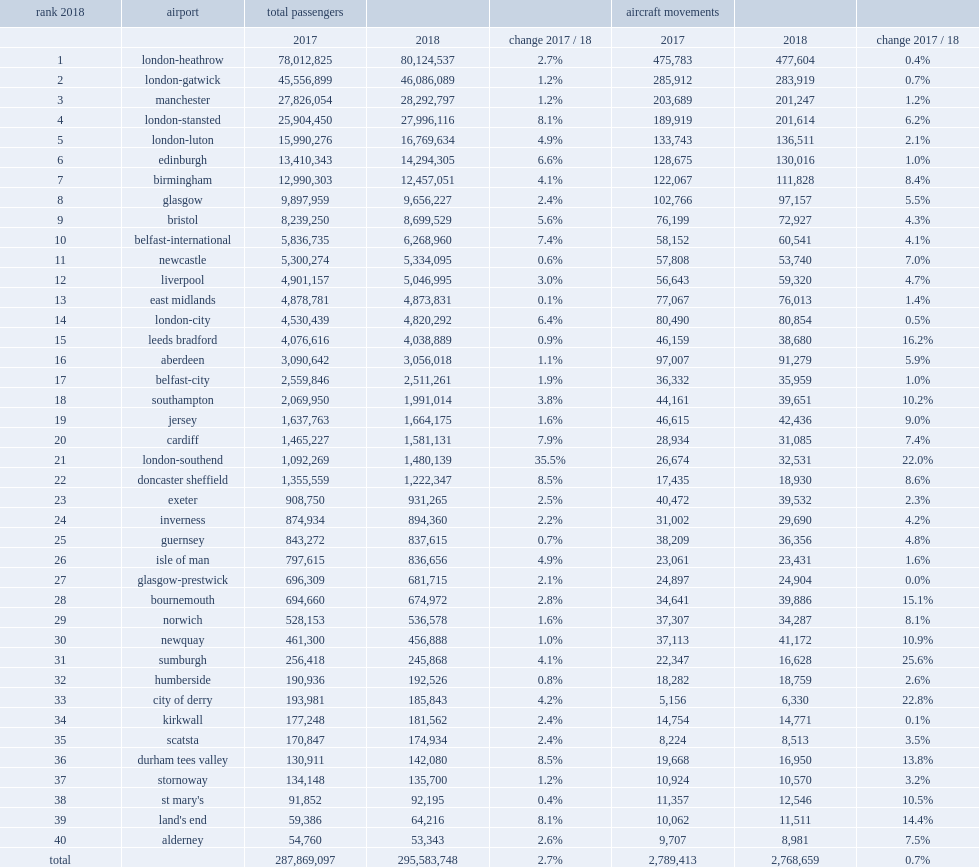Would you be able to parse every entry in this table? {'header': ['rank 2018', 'airport', 'total passengers', '', '', 'aircraft movements', '', ''], 'rows': [['', '', '2017', '2018', 'change 2017 / 18', '2017', '2018', 'change 2017 / 18'], ['1', 'london-heathrow', '78,012,825', '80,124,537', '2.7%', '475,783', '477,604', '0.4%'], ['2', 'london-gatwick', '45,556,899', '46,086,089', '1.2%', '285,912', '283,919', '0.7%'], ['3', 'manchester', '27,826,054', '28,292,797', '1.2%', '203,689', '201,247', '1.2%'], ['4', 'london-stansted', '25,904,450', '27,996,116', '8.1%', '189,919', '201,614', '6.2%'], ['5', 'london-luton', '15,990,276', '16,769,634', '4.9%', '133,743', '136,511', '2.1%'], ['6', 'edinburgh', '13,410,343', '14,294,305', '6.6%', '128,675', '130,016', '1.0%'], ['7', 'birmingham', '12,990,303', '12,457,051', '4.1%', '122,067', '111,828', '8.4%'], ['8', 'glasgow', '9,897,959', '9,656,227', '2.4%', '102,766', '97,157', '5.5%'], ['9', 'bristol', '8,239,250', '8,699,529', '5.6%', '76,199', '72,927', '4.3%'], ['10', 'belfast-international', '5,836,735', '6,268,960', '7.4%', '58,152', '60,541', '4.1%'], ['11', 'newcastle', '5,300,274', '5,334,095', '0.6%', '57,808', '53,740', '7.0%'], ['12', 'liverpool', '4,901,157', '5,046,995', '3.0%', '56,643', '59,320', '4.7%'], ['13', 'east midlands', '4,878,781', '4,873,831', '0.1%', '77,067', '76,013', '1.4%'], ['14', 'london-city', '4,530,439', '4,820,292', '6.4%', '80,490', '80,854', '0.5%'], ['15', 'leeds bradford', '4,076,616', '4,038,889', '0.9%', '46,159', '38,680', '16.2%'], ['16', 'aberdeen', '3,090,642', '3,056,018', '1.1%', '97,007', '91,279', '5.9%'], ['17', 'belfast-city', '2,559,846', '2,511,261', '1.9%', '36,332', '35,959', '1.0%'], ['18', 'southampton', '2,069,950', '1,991,014', '3.8%', '44,161', '39,651', '10.2%'], ['19', 'jersey', '1,637,763', '1,664,175', '1.6%', '46,615', '42,436', '9.0%'], ['20', 'cardiff', '1,465,227', '1,581,131', '7.9%', '28,934', '31,085', '7.4%'], ['21', 'london-southend', '1,092,269', '1,480,139', '35.5%', '26,674', '32,531', '22.0%'], ['22', 'doncaster sheffield', '1,355,559', '1,222,347', '8.5%', '17,435', '18,930', '8.6%'], ['23', 'exeter', '908,750', '931,265', '2.5%', '40,472', '39,532', '2.3%'], ['24', 'inverness', '874,934', '894,360', '2.2%', '31,002', '29,690', '4.2%'], ['25', 'guernsey', '843,272', '837,615', '0.7%', '38,209', '36,356', '4.8%'], ['26', 'isle of man', '797,615', '836,656', '4.9%', '23,061', '23,431', '1.6%'], ['27', 'glasgow-prestwick', '696,309', '681,715', '2.1%', '24,897', '24,904', '0.0%'], ['28', 'bournemouth', '694,660', '674,972', '2.8%', '34,641', '39,886', '15.1%'], ['29', 'norwich', '528,153', '536,578', '1.6%', '37,307', '34,287', '8.1%'], ['30', 'newquay', '461,300', '456,888', '1.0%', '37,113', '41,172', '10.9%'], ['31', 'sumburgh', '256,418', '245,868', '4.1%', '22,347', '16,628', '25.6%'], ['32', 'humberside', '190,936', '192,526', '0.8%', '18,282', '18,759', '2.6%'], ['33', 'city of derry', '193,981', '185,843', '4.2%', '5,156', '6,330', '22.8%'], ['34', 'kirkwall', '177,248', '181,562', '2.4%', '14,754', '14,771', '0.1%'], ['35', 'scatsta', '170,847', '174,934', '2.4%', '8,224', '8,513', '3.5%'], ['36', 'durham tees valley', '130,911', '142,080', '8.5%', '19,668', '16,950', '13.8%'], ['37', 'stornoway', '134,148', '135,700', '1.2%', '10,924', '10,570', '3.2%'], ['38', "st mary's", '91,852', '92,195', '0.4%', '11,357', '12,546', '10.5%'], ['39', "land's end", '59,386', '64,216', '8.1%', '10,062', '11,511', '14.4%'], ['40', 'alderney', '54,760', '53,343', '2.6%', '9,707', '8,981', '7.5%'], ['total', '', '287,869,097', '295,583,748', '2.7%', '2,789,413', '2,768,659', '0.7%']]} In 2017, which airport was the 29th busiest airport in the uk? Norwich. 